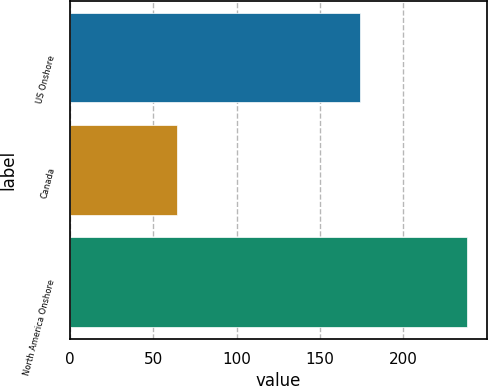Convert chart to OTSL. <chart><loc_0><loc_0><loc_500><loc_500><bar_chart><fcel>US Onshore<fcel>Canada<fcel>North America Onshore<nl><fcel>174<fcel>64<fcel>238<nl></chart> 